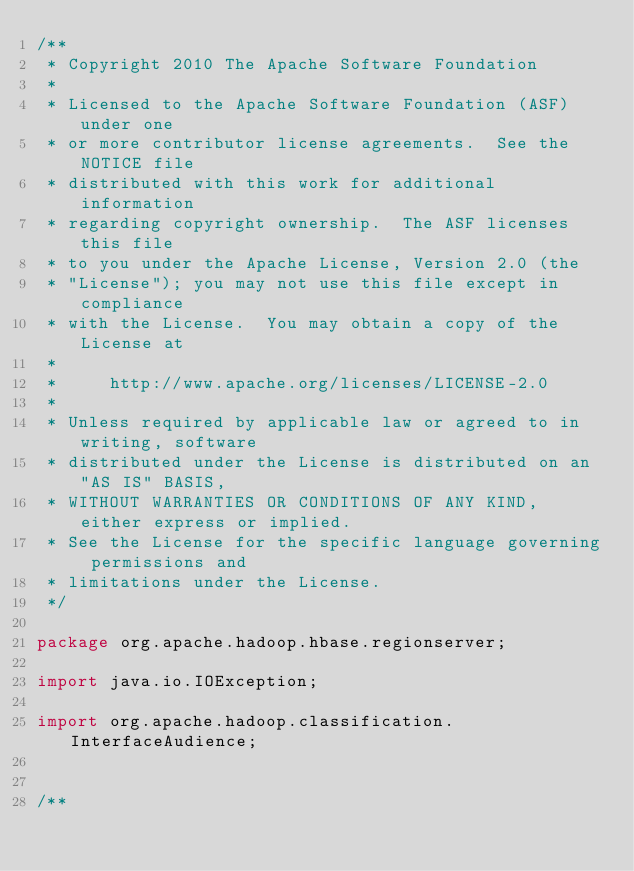Convert code to text. <code><loc_0><loc_0><loc_500><loc_500><_Java_>/**
 * Copyright 2010 The Apache Software Foundation
 *
 * Licensed to the Apache Software Foundation (ASF) under one
 * or more contributor license agreements.  See the NOTICE file
 * distributed with this work for additional information
 * regarding copyright ownership.  The ASF licenses this file
 * to you under the Apache License, Version 2.0 (the
 * "License"); you may not use this file except in compliance
 * with the License.  You may obtain a copy of the License at
 *
 *     http://www.apache.org/licenses/LICENSE-2.0
 *
 * Unless required by applicable law or agreed to in writing, software
 * distributed under the License is distributed on an "AS IS" BASIS,
 * WITHOUT WARRANTIES OR CONDITIONS OF ANY KIND, either express or implied.
 * See the License for the specific language governing permissions and
 * limitations under the License.
 */

package org.apache.hadoop.hbase.regionserver;

import java.io.IOException;

import org.apache.hadoop.classification.InterfaceAudience;


/**</code> 